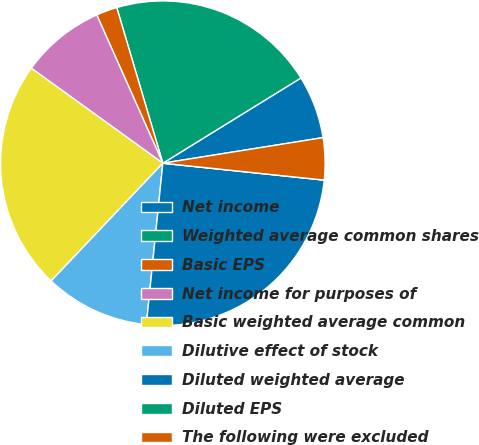Convert chart. <chart><loc_0><loc_0><loc_500><loc_500><pie_chart><fcel>Net income<fcel>Weighted average common shares<fcel>Basic EPS<fcel>Net income for purposes of<fcel>Basic weighted average common<fcel>Dilutive effect of stock<fcel>Diluted weighted average<fcel>Diluted EPS<fcel>The following were excluded<nl><fcel>6.28%<fcel>20.78%<fcel>2.09%<fcel>8.37%<fcel>22.87%<fcel>10.46%<fcel>24.96%<fcel>0.0%<fcel>4.18%<nl></chart> 